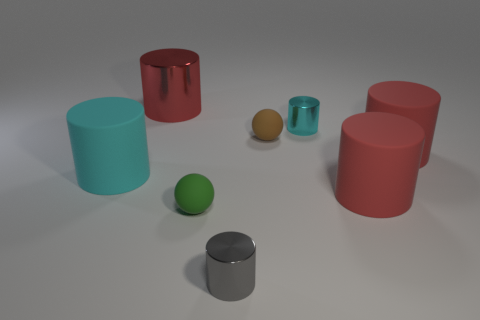How many other things are the same size as the cyan matte object?
Provide a short and direct response. 3. What is the material of the cyan thing right of the brown ball?
Ensure brevity in your answer.  Metal. Is the shape of the large red shiny thing the same as the cyan rubber thing?
Provide a short and direct response. Yes. What number of other things are there of the same shape as the green thing?
Keep it short and to the point. 1. There is a big object that is behind the small cyan shiny cylinder; what color is it?
Provide a succinct answer. Red. Is the size of the red metal thing the same as the green object?
Offer a very short reply. No. What is the large object that is behind the small rubber sphere that is behind the large cyan matte thing made of?
Provide a short and direct response. Metal. How many big cylinders have the same color as the large metal thing?
Your answer should be very brief. 2. Is there any other thing that is the same material as the gray thing?
Your answer should be compact. Yes. Is the number of tiny balls on the left side of the tiny brown rubber thing less than the number of tiny red things?
Provide a succinct answer. No. 